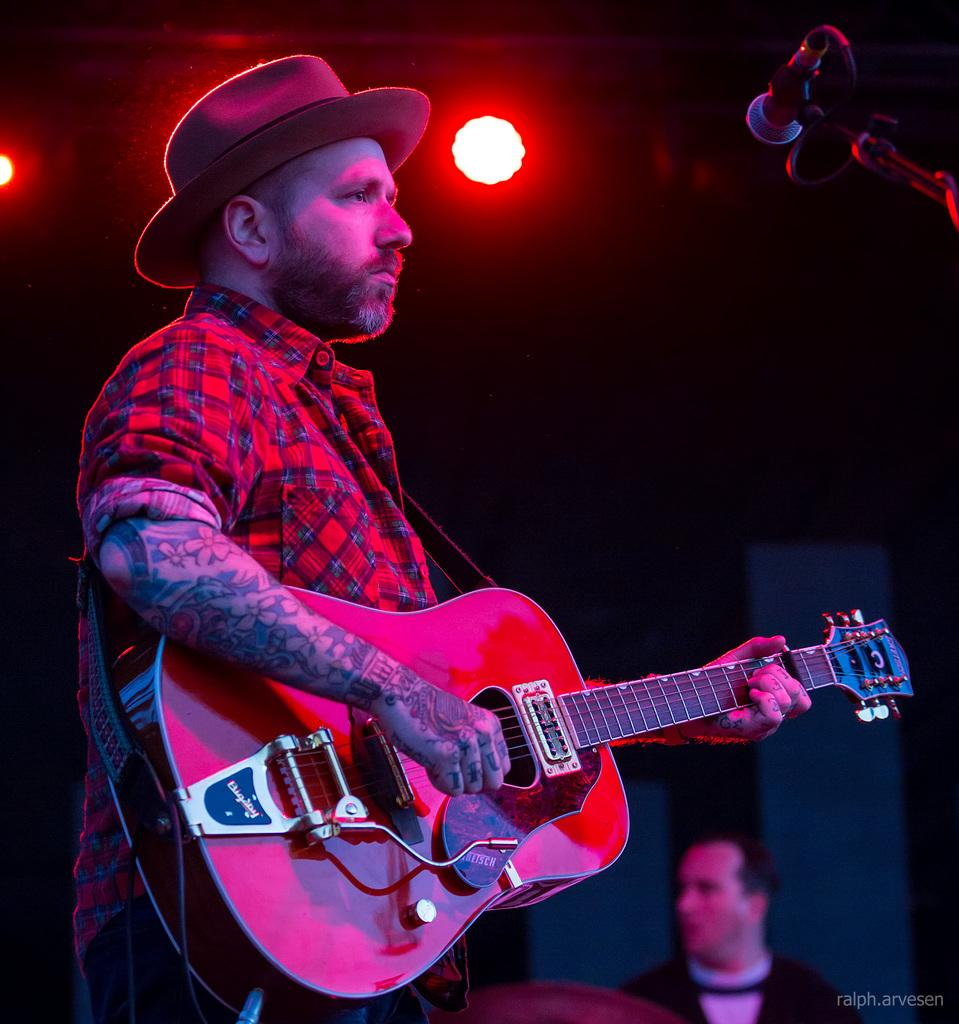Who is the person in the image? There is a man in the image. What is the man wearing on his head? The man is wearing a hat. What is the man doing in the image? The man is playing a guitar. Where is the guitar located in relation to the man? The guitar is in his hands. What object is present in the image that is typically used for amplifying sound? There is a microphone in the image. How does the man wash his hands while playing the guitar in the image? There is no indication in the image that the man is washing his hands while playing the guitar. 